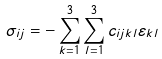Convert formula to latex. <formula><loc_0><loc_0><loc_500><loc_500>\sigma _ { i j } = - \sum _ { k = 1 } ^ { 3 } \sum _ { l = 1 } ^ { 3 } c _ { i j k l } \varepsilon _ { k l }</formula> 